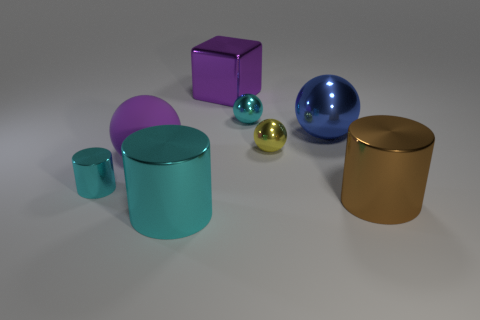How do the different colors of the objects affect the mood of this image? The varied colors of the objects, ranging from vibrant purple and blue to more subtle tones of brown and teal, create a sense of diversity and visual interest. The interplay of these colors generates a harmonious yet dynamic atmosphere, often associated with creativity and modernity. 